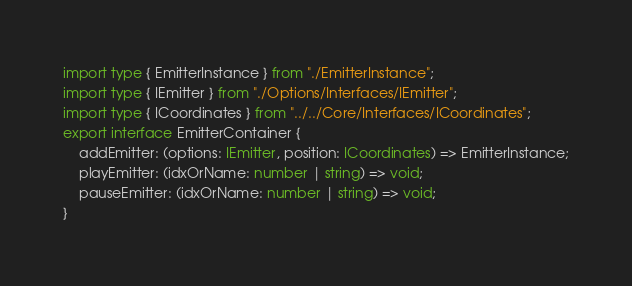<code> <loc_0><loc_0><loc_500><loc_500><_TypeScript_>import type { EmitterInstance } from "./EmitterInstance";
import type { IEmitter } from "./Options/Interfaces/IEmitter";
import type { ICoordinates } from "../../Core/Interfaces/ICoordinates";
export interface EmitterContainer {
    addEmitter: (options: IEmitter, position: ICoordinates) => EmitterInstance;
    playEmitter: (idxOrName: number | string) => void;
    pauseEmitter: (idxOrName: number | string) => void;
}
</code> 